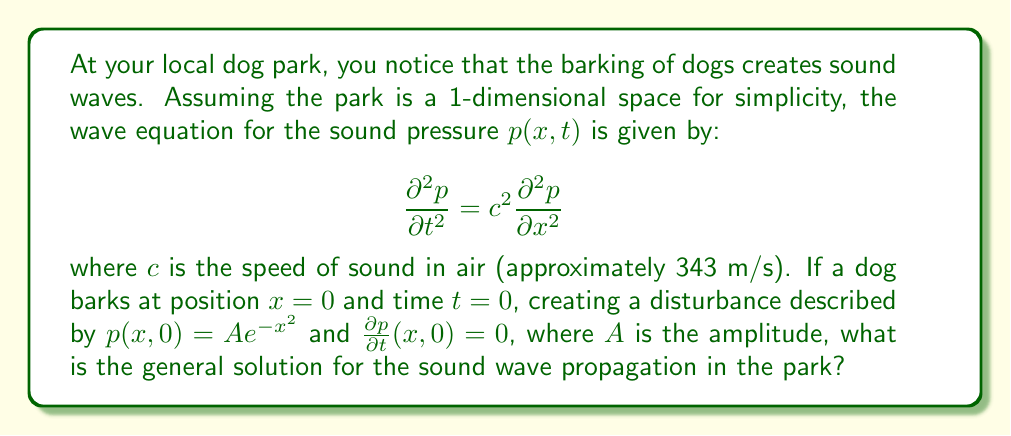Help me with this question. To solve this wave equation problem, we'll follow these steps:

1) The general solution to the 1D wave equation is given by D'Alembert's formula:

   $$p(x,t) = \frac{1}{2}[f(x-ct) + f(x+ct)] + \frac{1}{2c}\int_{x-ct}^{x+ct} g(s) ds$$

   where $f$ and $g$ are determined by the initial conditions.

2) From the initial conditions:
   
   $p(x,0) = Ae^{-x^2} = f(x)$
   $\frac{\partial p}{\partial t}(x,0) = 0 = g(x)$

3) Since $g(x) = 0$, the integral term in D'Alembert's formula vanishes:

   $$p(x,t) = \frac{1}{2}[f(x-ct) + f(x+ct)]$$

4) Substituting $f(x) = Ae^{-x^2}$:

   $$p(x,t) = \frac{1}{2}[Ae^{-(x-ct)^2} + Ae^{-(x+ct)^2}]$$

5) This can be simplified to:

   $$p(x,t) = \frac{A}{2}[e^{-(x-ct)^2} + e^{-(x+ct)^2}]$$

This is the general solution for the sound wave propagation in the park.
Answer: $$p(x,t) = \frac{A}{2}[e^{-(x-ct)^2} + e^{-(x+ct)^2}]$$ 